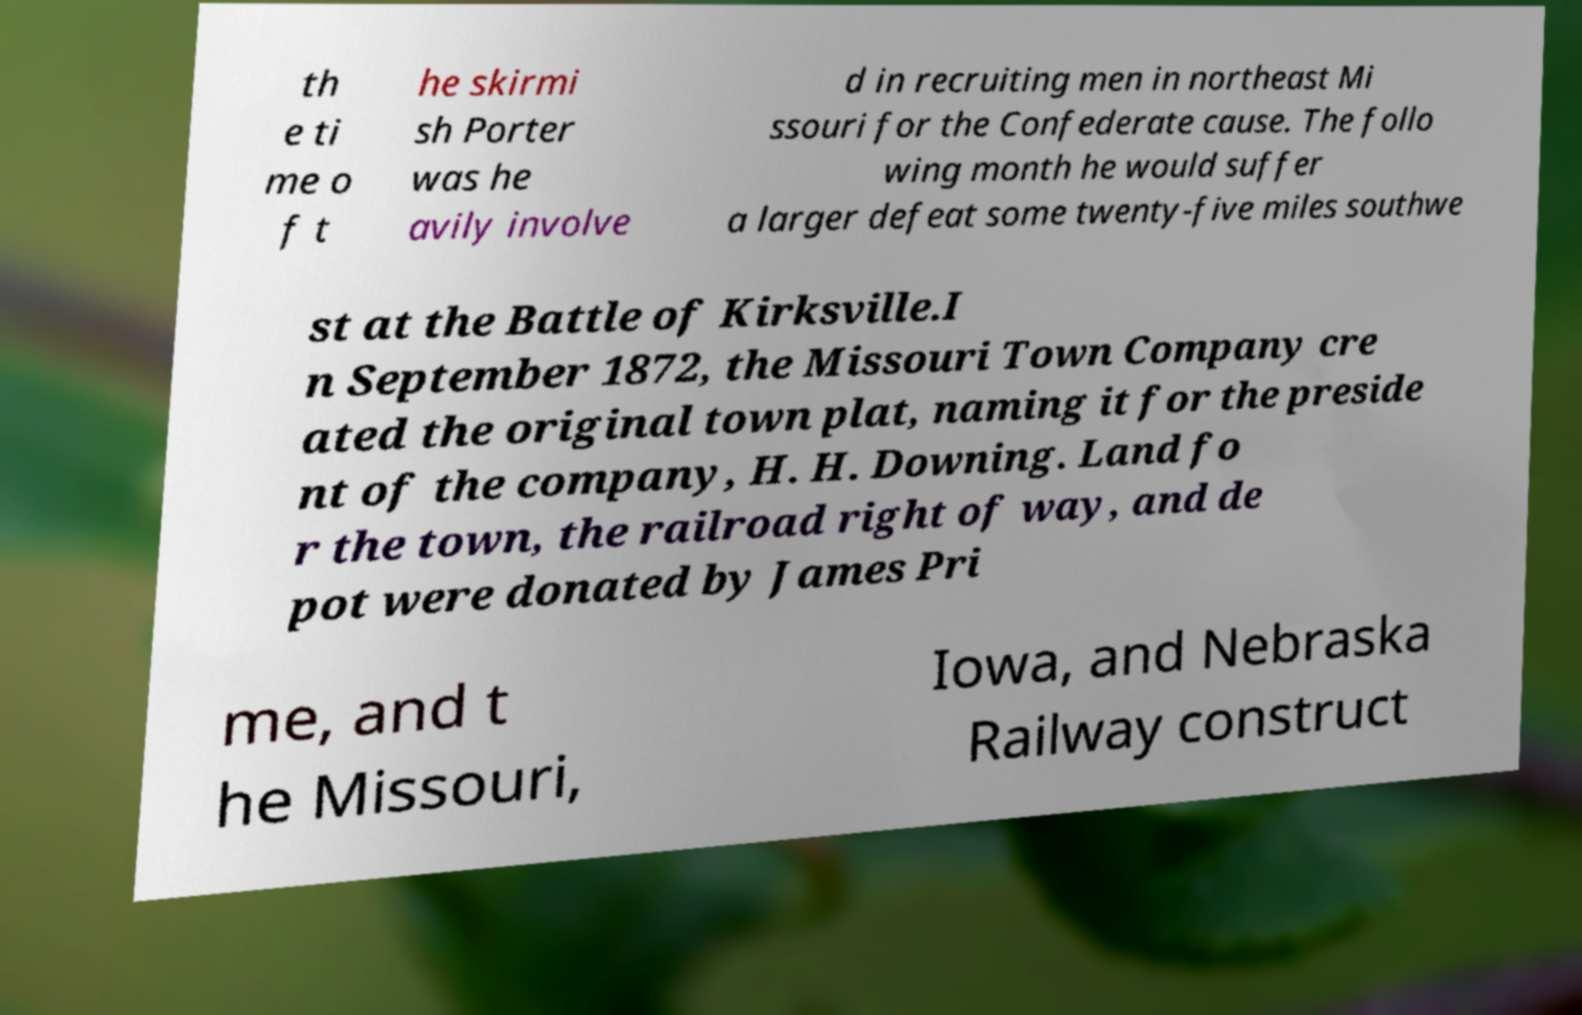Please identify and transcribe the text found in this image. th e ti me o f t he skirmi sh Porter was he avily involve d in recruiting men in northeast Mi ssouri for the Confederate cause. The follo wing month he would suffer a larger defeat some twenty-five miles southwe st at the Battle of Kirksville.I n September 1872, the Missouri Town Company cre ated the original town plat, naming it for the preside nt of the company, H. H. Downing. Land fo r the town, the railroad right of way, and de pot were donated by James Pri me, and t he Missouri, Iowa, and Nebraska Railway construct 